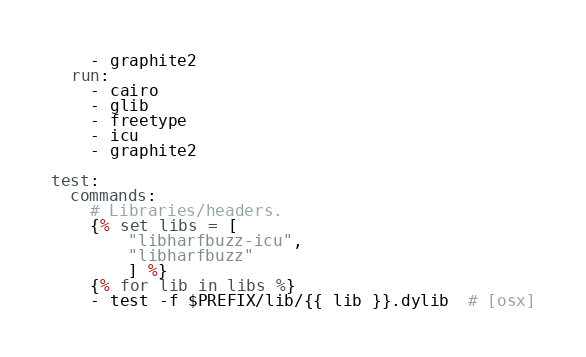Convert code to text. <code><loc_0><loc_0><loc_500><loc_500><_YAML_>    - graphite2
  run:
    - cairo
    - glib
    - freetype
    - icu
    - graphite2

test:
  commands:
    # Libraries/headers.
    {% set libs = [
        "libharfbuzz-icu",
        "libharfbuzz"
        ] %}
    {% for lib in libs %}
    - test -f $PREFIX/lib/{{ lib }}.dylib  # [osx]</code> 